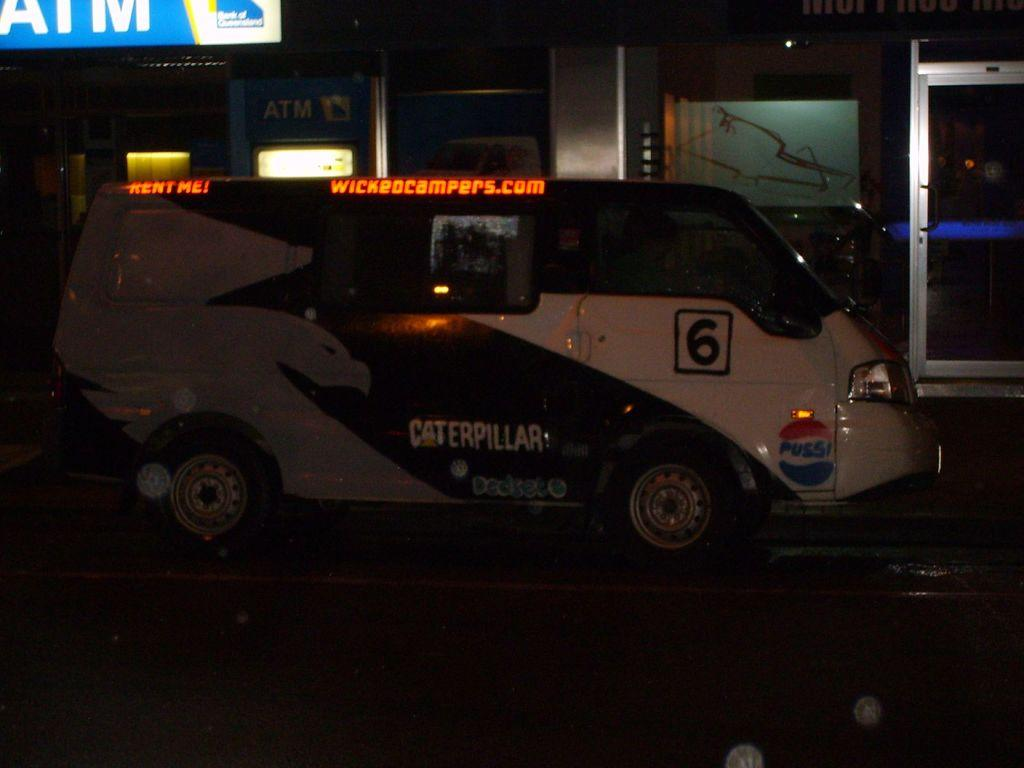What is the main subject in the center of the image? There is a vehicle in the center of the image. Can you describe any specific details about the vehicle? The vehicle has some text on it. What can be seen in the background of the image? There is a wall and lights in the background of the image, along with a few other objects. Is there a chair visible in the image? No, there is no chair present in the image. Can you describe the locket that the man is wearing in the image? There is no man or locket present in the image. 